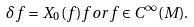Convert formula to latex. <formula><loc_0><loc_0><loc_500><loc_500>\delta f = X _ { 0 } ( f ) f o r f \in C ^ { \infty } ( M ) .</formula> 